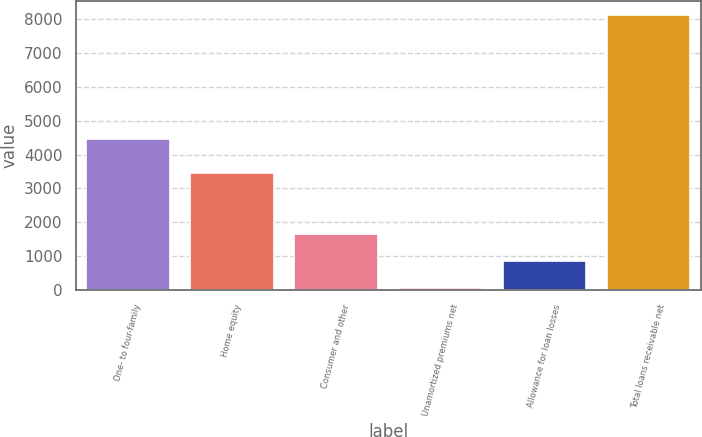Convert chart. <chart><loc_0><loc_0><loc_500><loc_500><bar_chart><fcel>One- to four-family<fcel>Home equity<fcel>Consumer and other<fcel>Unamortized premiums net<fcel>Allowance for loan losses<fcel>Total loans receivable net<nl><fcel>4474.8<fcel>3454<fcel>1660.28<fcel>44.7<fcel>852.49<fcel>8122.6<nl></chart> 